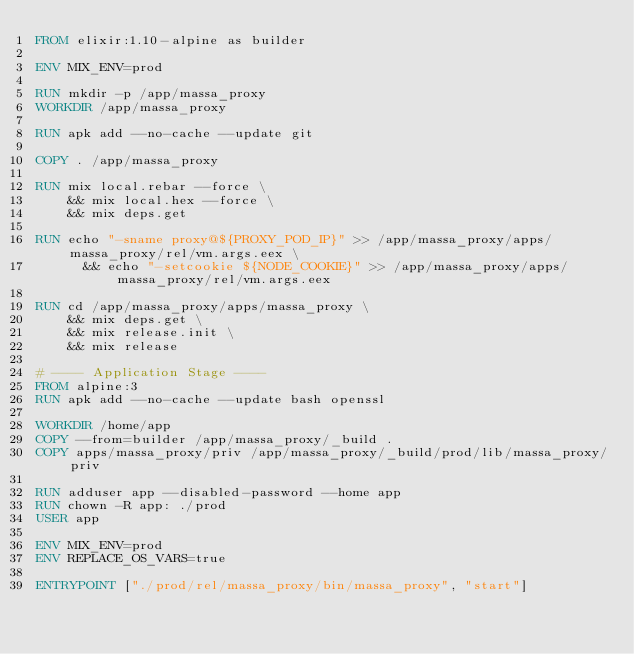<code> <loc_0><loc_0><loc_500><loc_500><_Dockerfile_>FROM elixir:1.10-alpine as builder

ENV MIX_ENV=prod

RUN mkdir -p /app/massa_proxy
WORKDIR /app/massa_proxy

RUN apk add --no-cache --update git

COPY . /app/massa_proxy

RUN mix local.rebar --force \
    && mix local.hex --force \
    && mix deps.get 

RUN echo "-sname proxy@${PROXY_POD_IP}" >> /app/massa_proxy/apps/massa_proxy/rel/vm.args.eex \
      && echo "-setcookie ${NODE_COOKIE}" >> /app/massa_proxy/apps/massa_proxy/rel/vm.args.eex

RUN cd /app/massa_proxy/apps/massa_proxy \
    && mix deps.get \
    && mix release.init \
    && mix release

# ---- Application Stage ----
FROM alpine:3
RUN apk add --no-cache --update bash openssl

WORKDIR /home/app
COPY --from=builder /app/massa_proxy/_build .
COPY apps/massa_proxy/priv /app/massa_proxy/_build/prod/lib/massa_proxy/priv

RUN adduser app --disabled-password --home app
RUN chown -R app: ./prod
USER app

ENV MIX_ENV=prod
ENV REPLACE_OS_VARS=true

ENTRYPOINT ["./prod/rel/massa_proxy/bin/massa_proxy", "start"]
</code> 